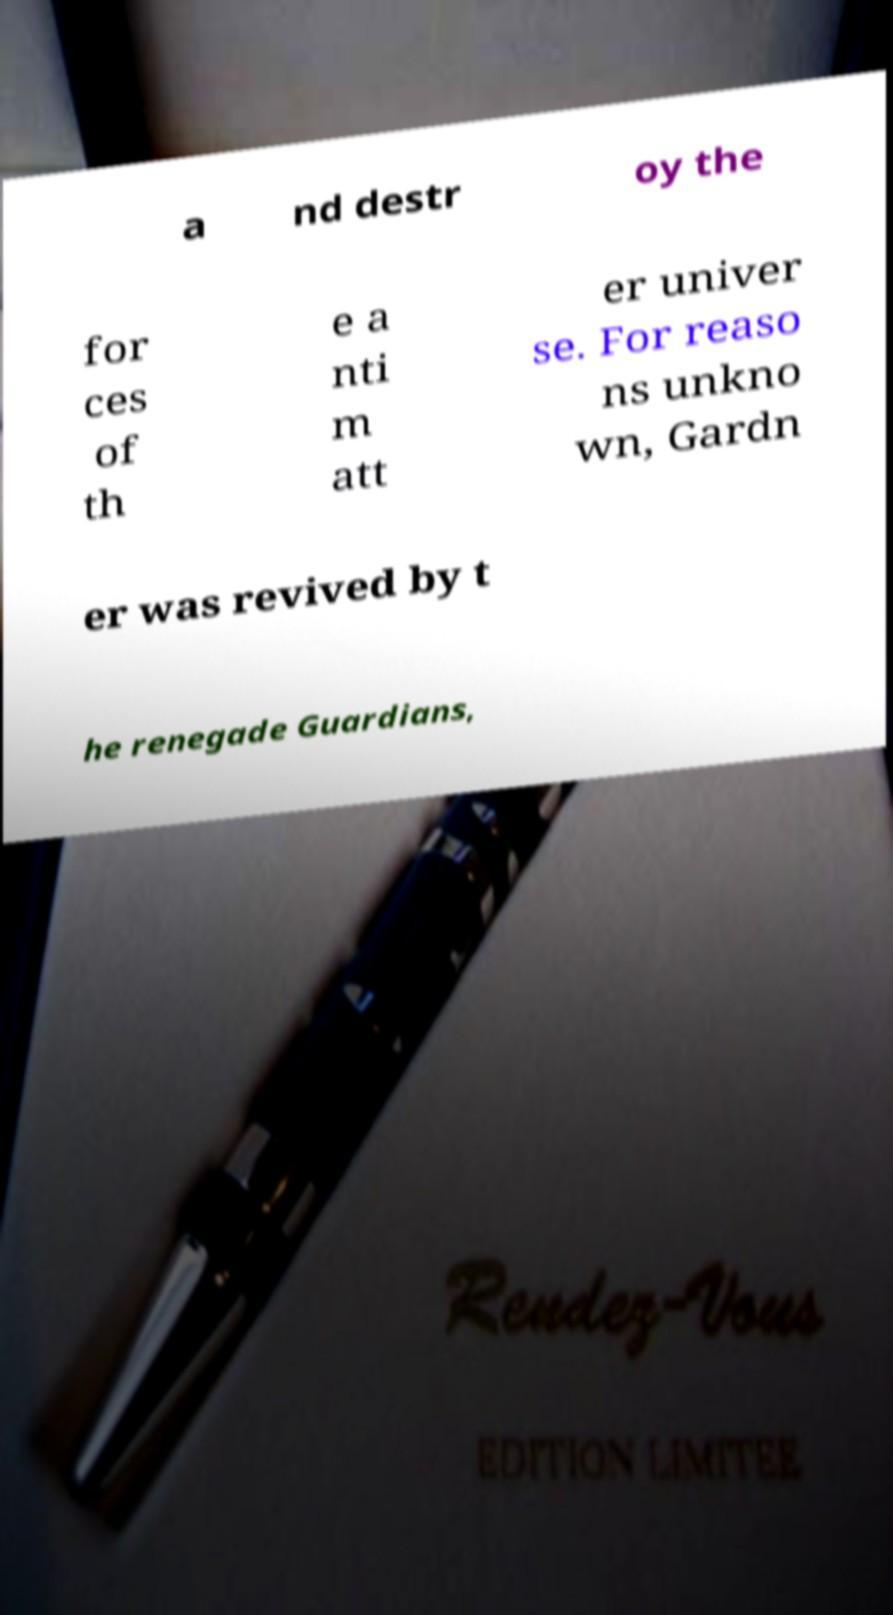Could you assist in decoding the text presented in this image and type it out clearly? a nd destr oy the for ces of th e a nti m att er univer se. For reaso ns unkno wn, Gardn er was revived by t he renegade Guardians, 